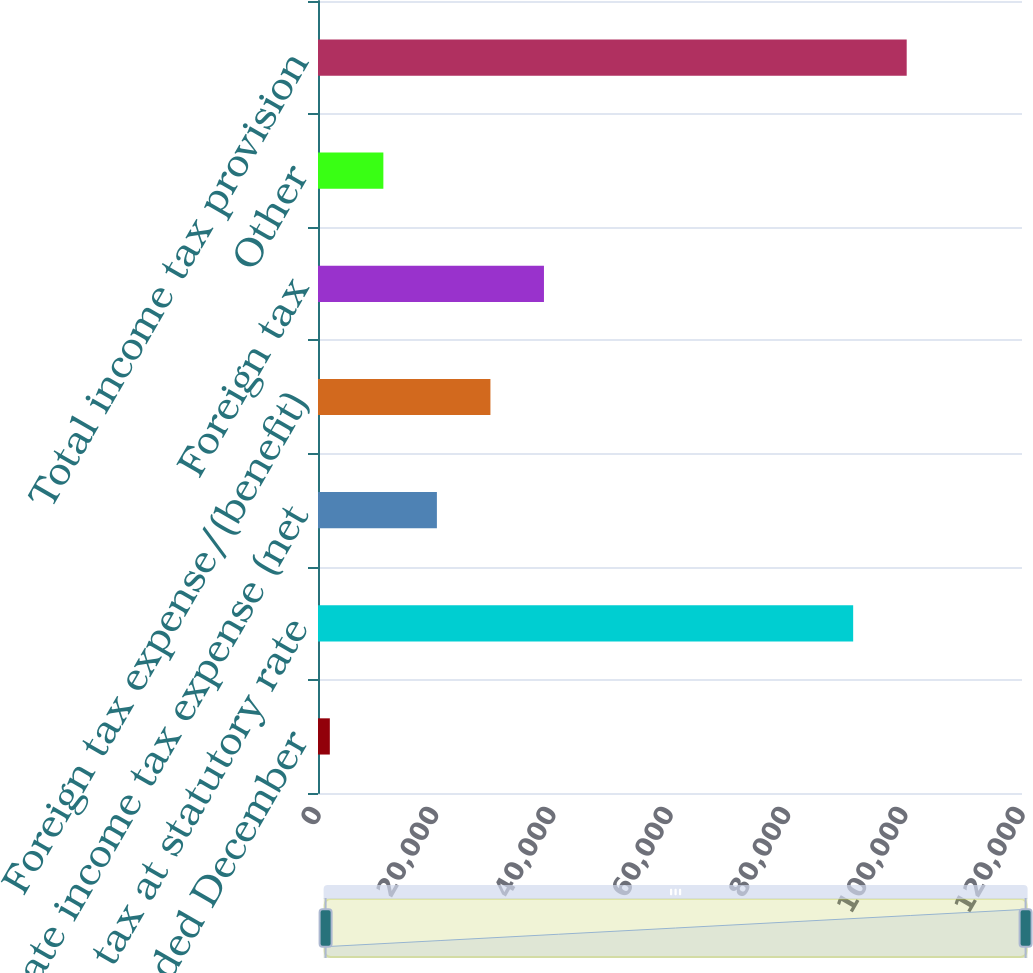<chart> <loc_0><loc_0><loc_500><loc_500><bar_chart><fcel>For the years ended December<fcel>Income tax at statutory rate<fcel>State income tax expense (net<fcel>Foreign tax expense/(benefit)<fcel>Foreign tax<fcel>Other<fcel>Total income tax provision<nl><fcel>2016<fcel>91222<fcel>20266.2<fcel>29391.3<fcel>38516.4<fcel>11141.1<fcel>100347<nl></chart> 